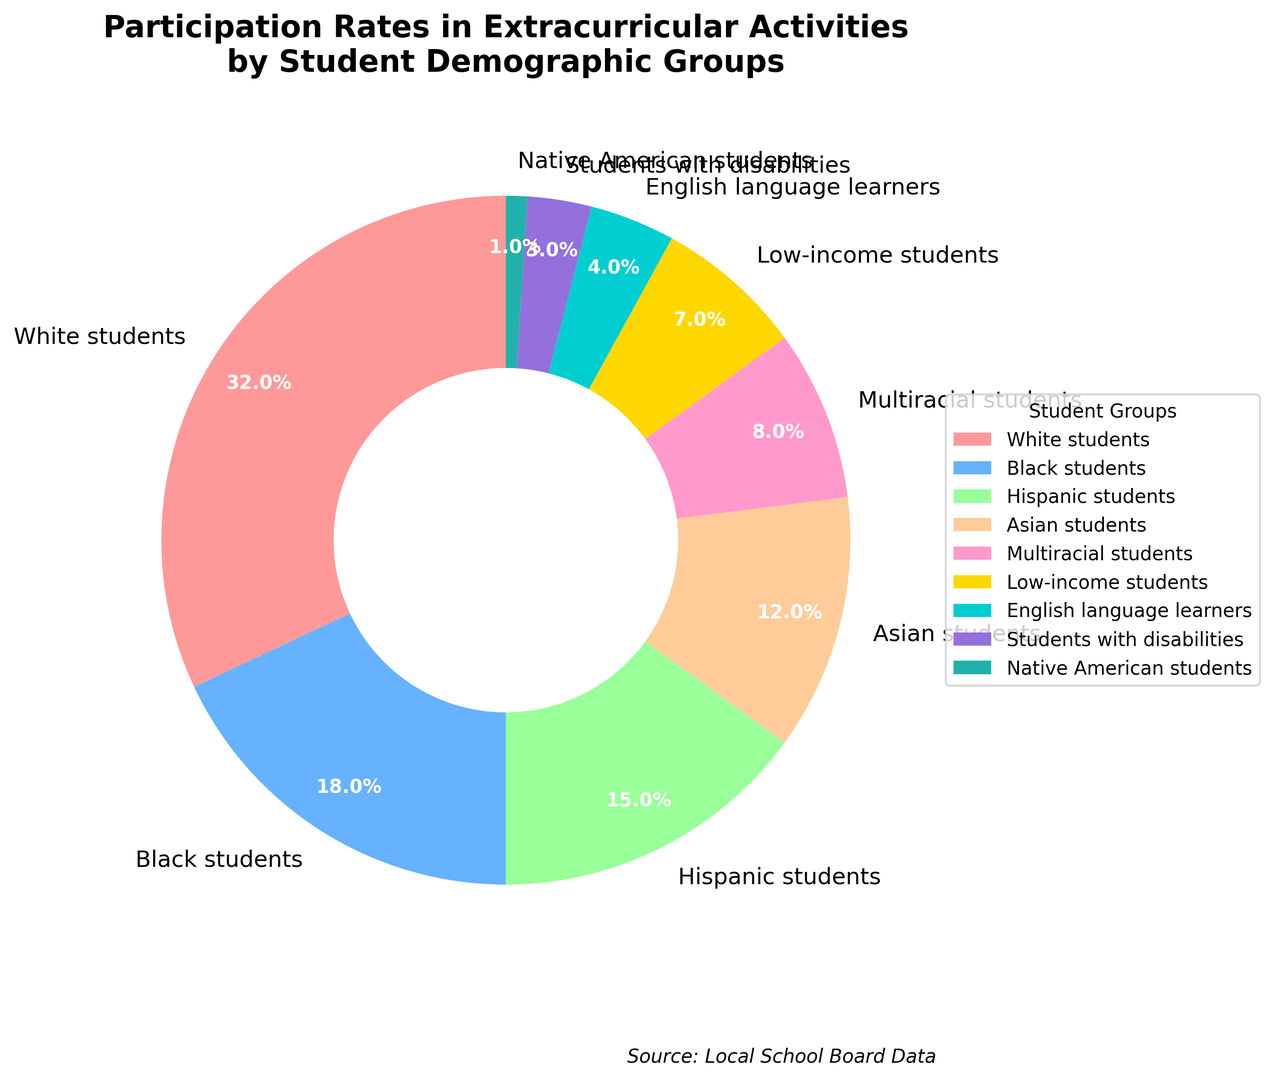Which student demographic group has the highest participation rate? By observing the pie chart, we can see that the group with the largest segment is "White students." The percentage label on this segment verifies that their participation rate is the highest at 32%.
Answer: White students What is the total participation rate for both White and Asian students combined? The participation rate for White students is 32% and for Asian students is 12%. By summing these two values, 32% + 12% = 44%.
Answer: 44% How much higher is the participation rate of Hispanic students compared to Students with disabilities? The participation rate for Hispanic students is 15% while for Students with disabilities it is 3%. The difference between these two values is 15% - 3% = 12%.
Answer: 12% Which two demographic groups have the closest participation rates? By examining the pie chart, we can observe the segments and their corresponding percentages. The two closest participation rates are for Multiracial students (8%) and Low-income students (7%).
Answer: Multiracial students and Low-income students What is the average participation rate for Black, Hispanic, and Asian students? The participation rates for Black, Hispanic, and Asian students are 18%, 15%, and 12% respectively. To calculate the average, sum these values and divide by 3. (18% + 15% + 12%) / 3 = 15%.
Answer: 15% Which group has a larger participation rate: English language learners or Students with disabilities? The pie chart indicates that English language learners have a participation rate of 4% and Students with disabilities have a rate of 3%. Hence, English language learners have a larger participation rate.
Answer: English language learners If White students' participation rate were to decrease by 5%, what would their new rate be? The original participation rate for White students is 32%. Decreasing this by 5%, we calculate: 32% - 5% = 27%. Their new participation rate would be 27%.
Answer: 27% What percent of the total participation rate do Native American students represent? Native American students have a participation rate of 1%. By examining the pie chart, it is clear that they represent the smallest segment of total participation.
Answer: 1% Between Low-income students and English language learners, which group has a higher participation rate, and by how much? Low-income students have a participation rate of 7%, and English language learners have 4%. The difference is 7% - 4% = 3%. Thus, Low-income students have a higher participation rate by 3%.
Answer: Low-income students by 3% 